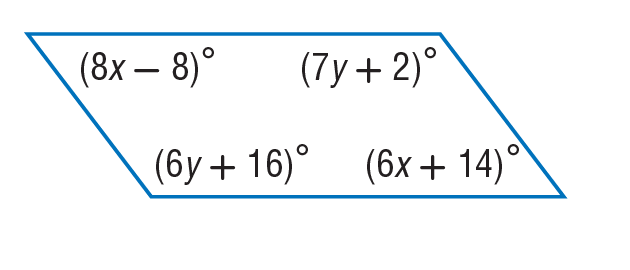Answer the mathemtical geometry problem and directly provide the correct option letter.
Question: Find x so that the quadrilateral is a parallelogram.
Choices: A: 11 B: 14 C: 77 D: 98 A 